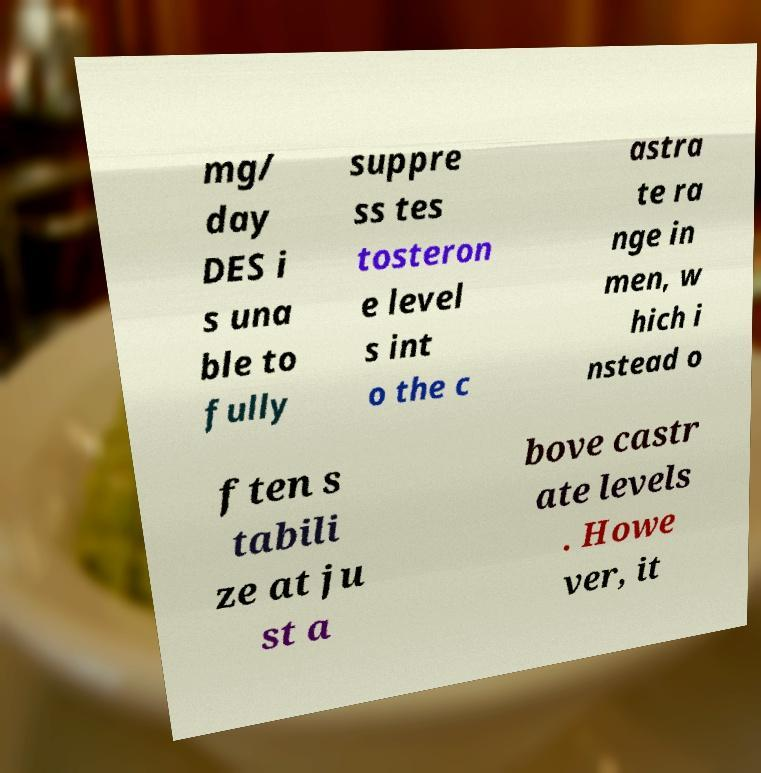Please identify and transcribe the text found in this image. mg/ day DES i s una ble to fully suppre ss tes tosteron e level s int o the c astra te ra nge in men, w hich i nstead o ften s tabili ze at ju st a bove castr ate levels . Howe ver, it 